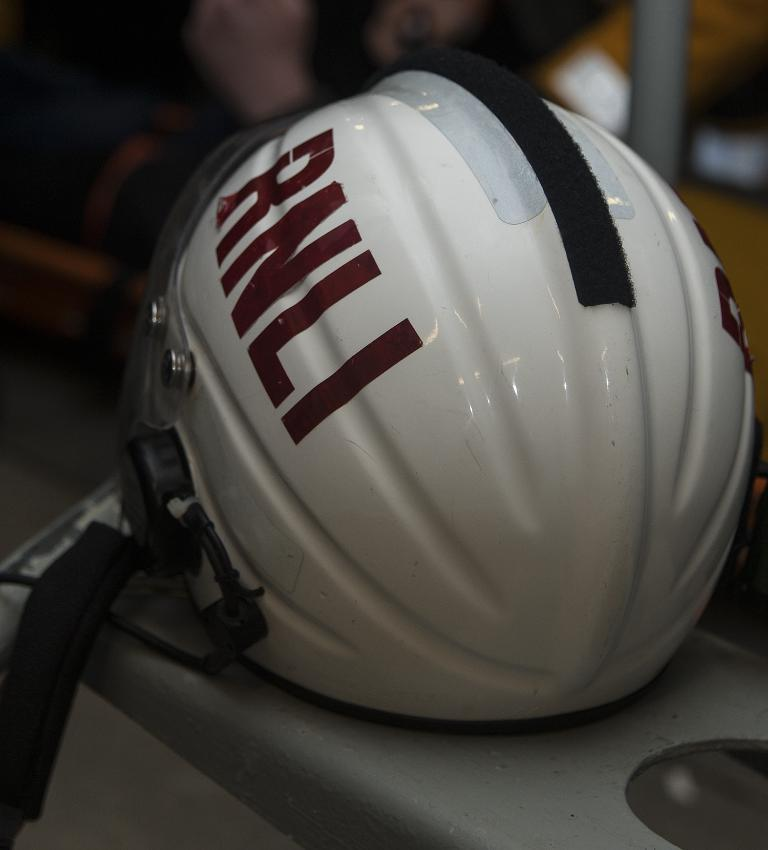What color is the helmet in the image? The helmet in the image is white. Where is the helmet located in the image? The helmet is placed on a table. Can you describe the background of the image? The background of the image is blurred. What does the parent say about the mouth of the helmet in the image? There is no parent or mouth mentioned in the image, as it only features a white helmet placed on a table with a blurred background. 